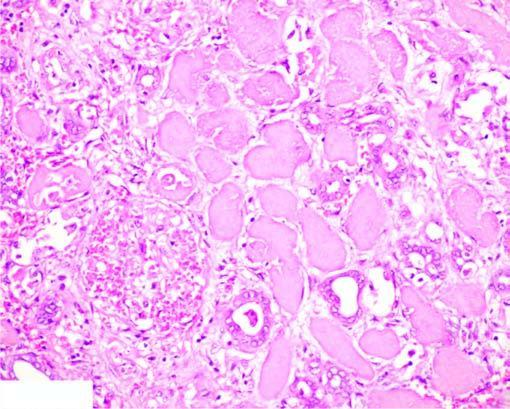what do the nuclei show?
Answer the question using a single word or phrase. Granular debris 